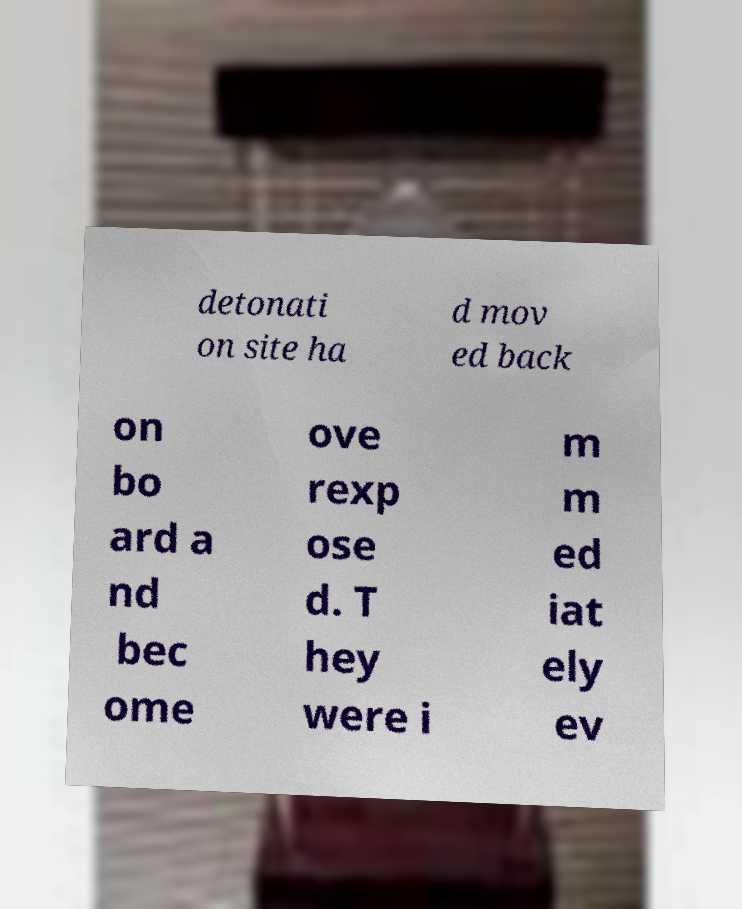Please identify and transcribe the text found in this image. detonati on site ha d mov ed back on bo ard a nd bec ome ove rexp ose d. T hey were i m m ed iat ely ev 